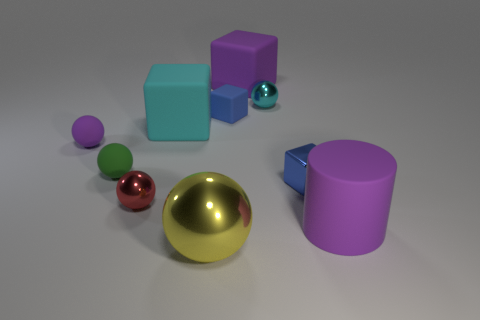Subtract all large purple cubes. How many cubes are left? 3 Subtract all yellow spheres. How many spheres are left? 4 Subtract 4 spheres. How many spheres are left? 1 Subtract all cylinders. How many objects are left? 9 Add 4 purple rubber spheres. How many purple rubber spheres are left? 5 Add 1 tiny blue metallic balls. How many tiny blue metallic balls exist? 1 Subtract 0 gray blocks. How many objects are left? 10 Subtract all red spheres. Subtract all gray cylinders. How many spheres are left? 4 Subtract all green balls. How many blue cubes are left? 2 Subtract all purple matte blocks. Subtract all cyan cubes. How many objects are left? 8 